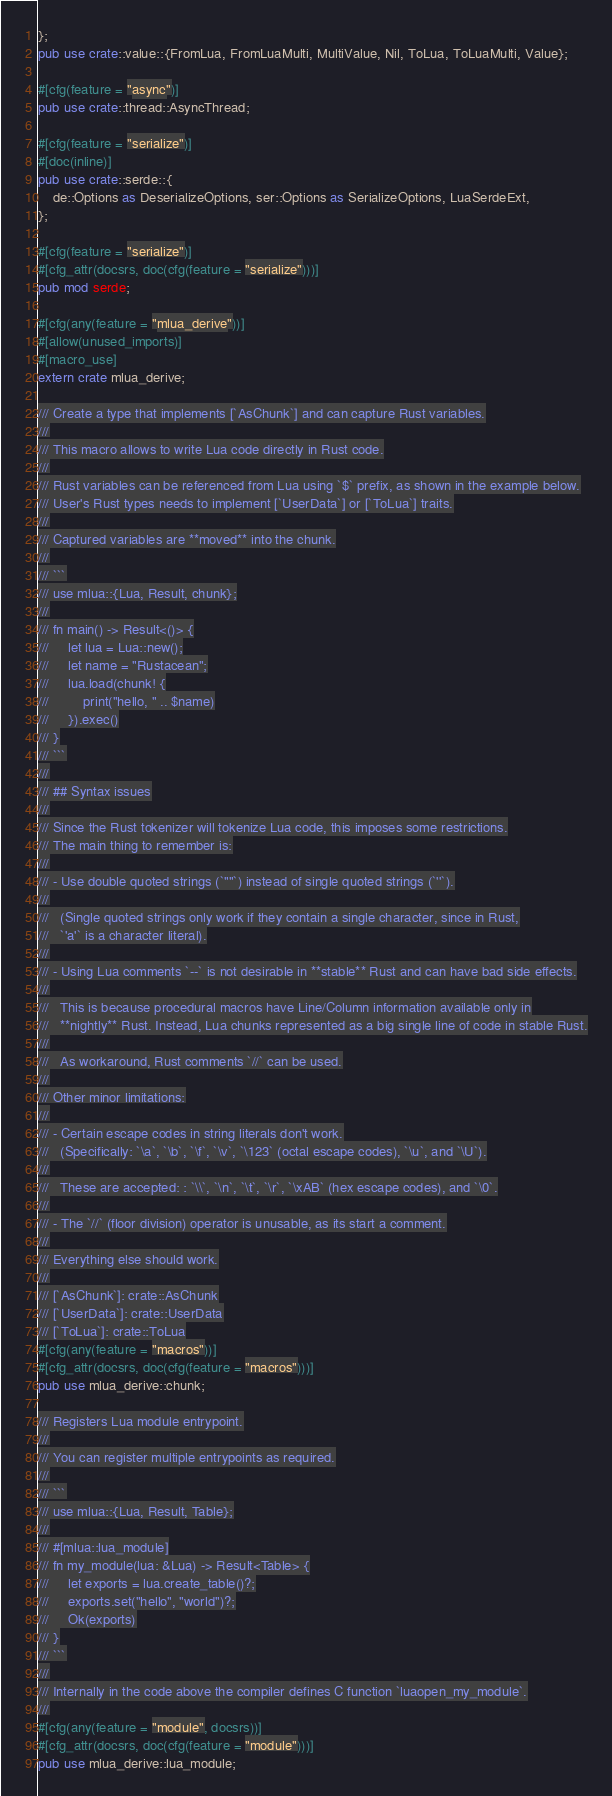<code> <loc_0><loc_0><loc_500><loc_500><_Rust_>};
pub use crate::value::{FromLua, FromLuaMulti, MultiValue, Nil, ToLua, ToLuaMulti, Value};

#[cfg(feature = "async")]
pub use crate::thread::AsyncThread;

#[cfg(feature = "serialize")]
#[doc(inline)]
pub use crate::serde::{
    de::Options as DeserializeOptions, ser::Options as SerializeOptions, LuaSerdeExt,
};

#[cfg(feature = "serialize")]
#[cfg_attr(docsrs, doc(cfg(feature = "serialize")))]
pub mod serde;

#[cfg(any(feature = "mlua_derive"))]
#[allow(unused_imports)]
#[macro_use]
extern crate mlua_derive;

/// Create a type that implements [`AsChunk`] and can capture Rust variables.
///
/// This macro allows to write Lua code directly in Rust code.
///
/// Rust variables can be referenced from Lua using `$` prefix, as shown in the example below.
/// User's Rust types needs to implement [`UserData`] or [`ToLua`] traits.
///
/// Captured variables are **moved** into the chunk.
///
/// ```
/// use mlua::{Lua, Result, chunk};
///
/// fn main() -> Result<()> {
///     let lua = Lua::new();
///     let name = "Rustacean";
///     lua.load(chunk! {
///         print("hello, " .. $name)
///     }).exec()
/// }
/// ```
///
/// ## Syntax issues
///
/// Since the Rust tokenizer will tokenize Lua code, this imposes some restrictions.
/// The main thing to remember is:
///
/// - Use double quoted strings (`""`) instead of single quoted strings (`''`).
///
///   (Single quoted strings only work if they contain a single character, since in Rust,
///   `'a'` is a character literal).
///
/// - Using Lua comments `--` is not desirable in **stable** Rust and can have bad side effects.
///
///   This is because procedural macros have Line/Column information available only in
///   **nightly** Rust. Instead, Lua chunks represented as a big single line of code in stable Rust.
///
///   As workaround, Rust comments `//` can be used.
///
/// Other minor limitations:
///
/// - Certain escape codes in string literals don't work.
///   (Specifically: `\a`, `\b`, `\f`, `\v`, `\123` (octal escape codes), `\u`, and `\U`).
///
///   These are accepted: : `\\`, `\n`, `\t`, `\r`, `\xAB` (hex escape codes), and `\0`.
///
/// - The `//` (floor division) operator is unusable, as its start a comment.
///
/// Everything else should work.
///
/// [`AsChunk`]: crate::AsChunk
/// [`UserData`]: crate::UserData
/// [`ToLua`]: crate::ToLua
#[cfg(any(feature = "macros"))]
#[cfg_attr(docsrs, doc(cfg(feature = "macros")))]
pub use mlua_derive::chunk;

/// Registers Lua module entrypoint.
///
/// You can register multiple entrypoints as required.
///
/// ```
/// use mlua::{Lua, Result, Table};
///
/// #[mlua::lua_module]
/// fn my_module(lua: &Lua) -> Result<Table> {
///     let exports = lua.create_table()?;
///     exports.set("hello", "world")?;
///     Ok(exports)
/// }
/// ```
///
/// Internally in the code above the compiler defines C function `luaopen_my_module`.
///
#[cfg(any(feature = "module", docsrs))]
#[cfg_attr(docsrs, doc(cfg(feature = "module")))]
pub use mlua_derive::lua_module;
</code> 